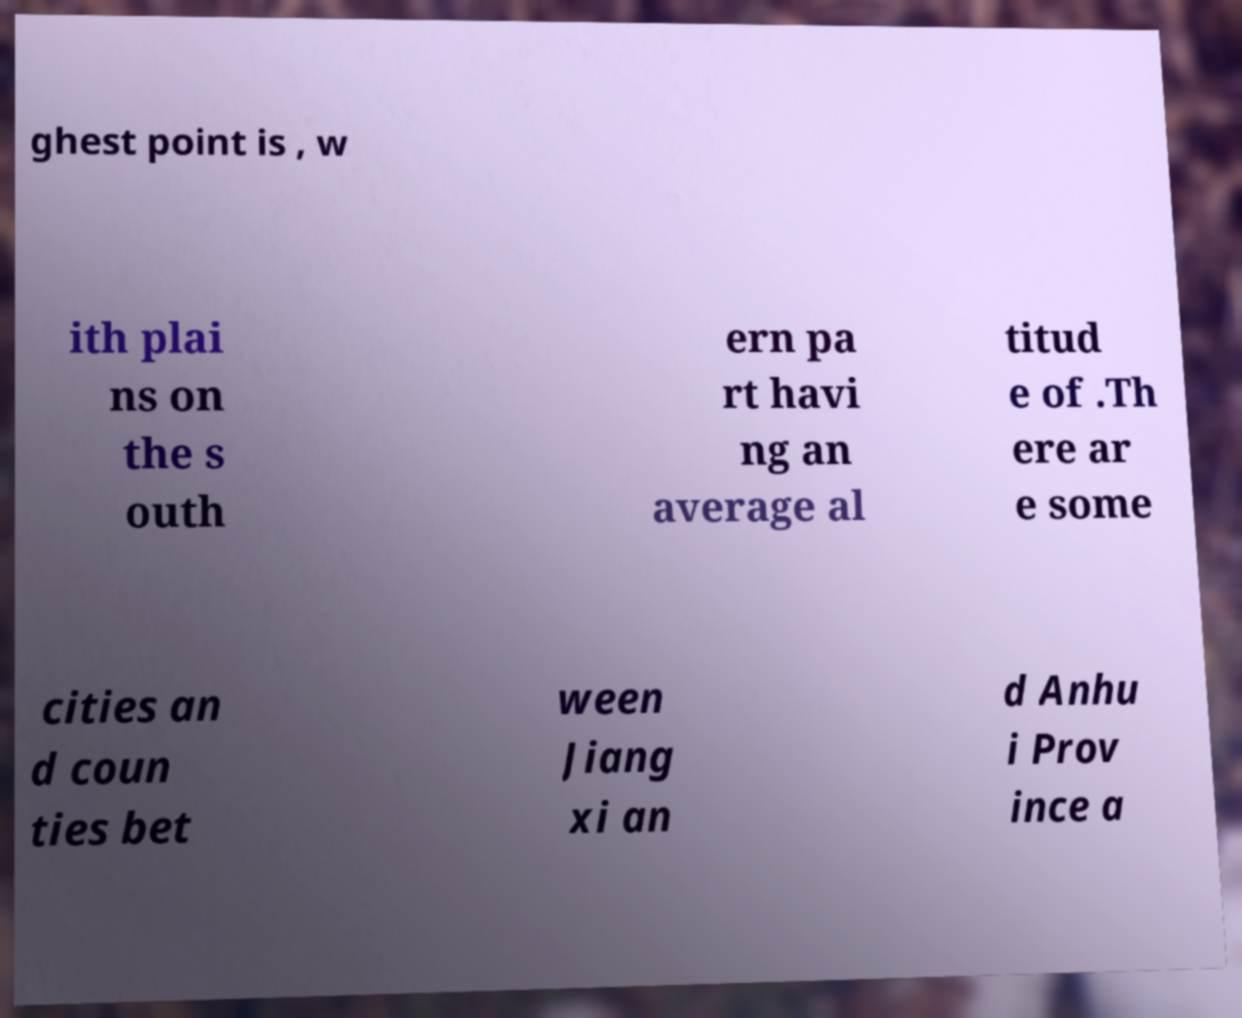Can you read and provide the text displayed in the image?This photo seems to have some interesting text. Can you extract and type it out for me? ghest point is , w ith plai ns on the s outh ern pa rt havi ng an average al titud e of .Th ere ar e some cities an d coun ties bet ween Jiang xi an d Anhu i Prov ince a 